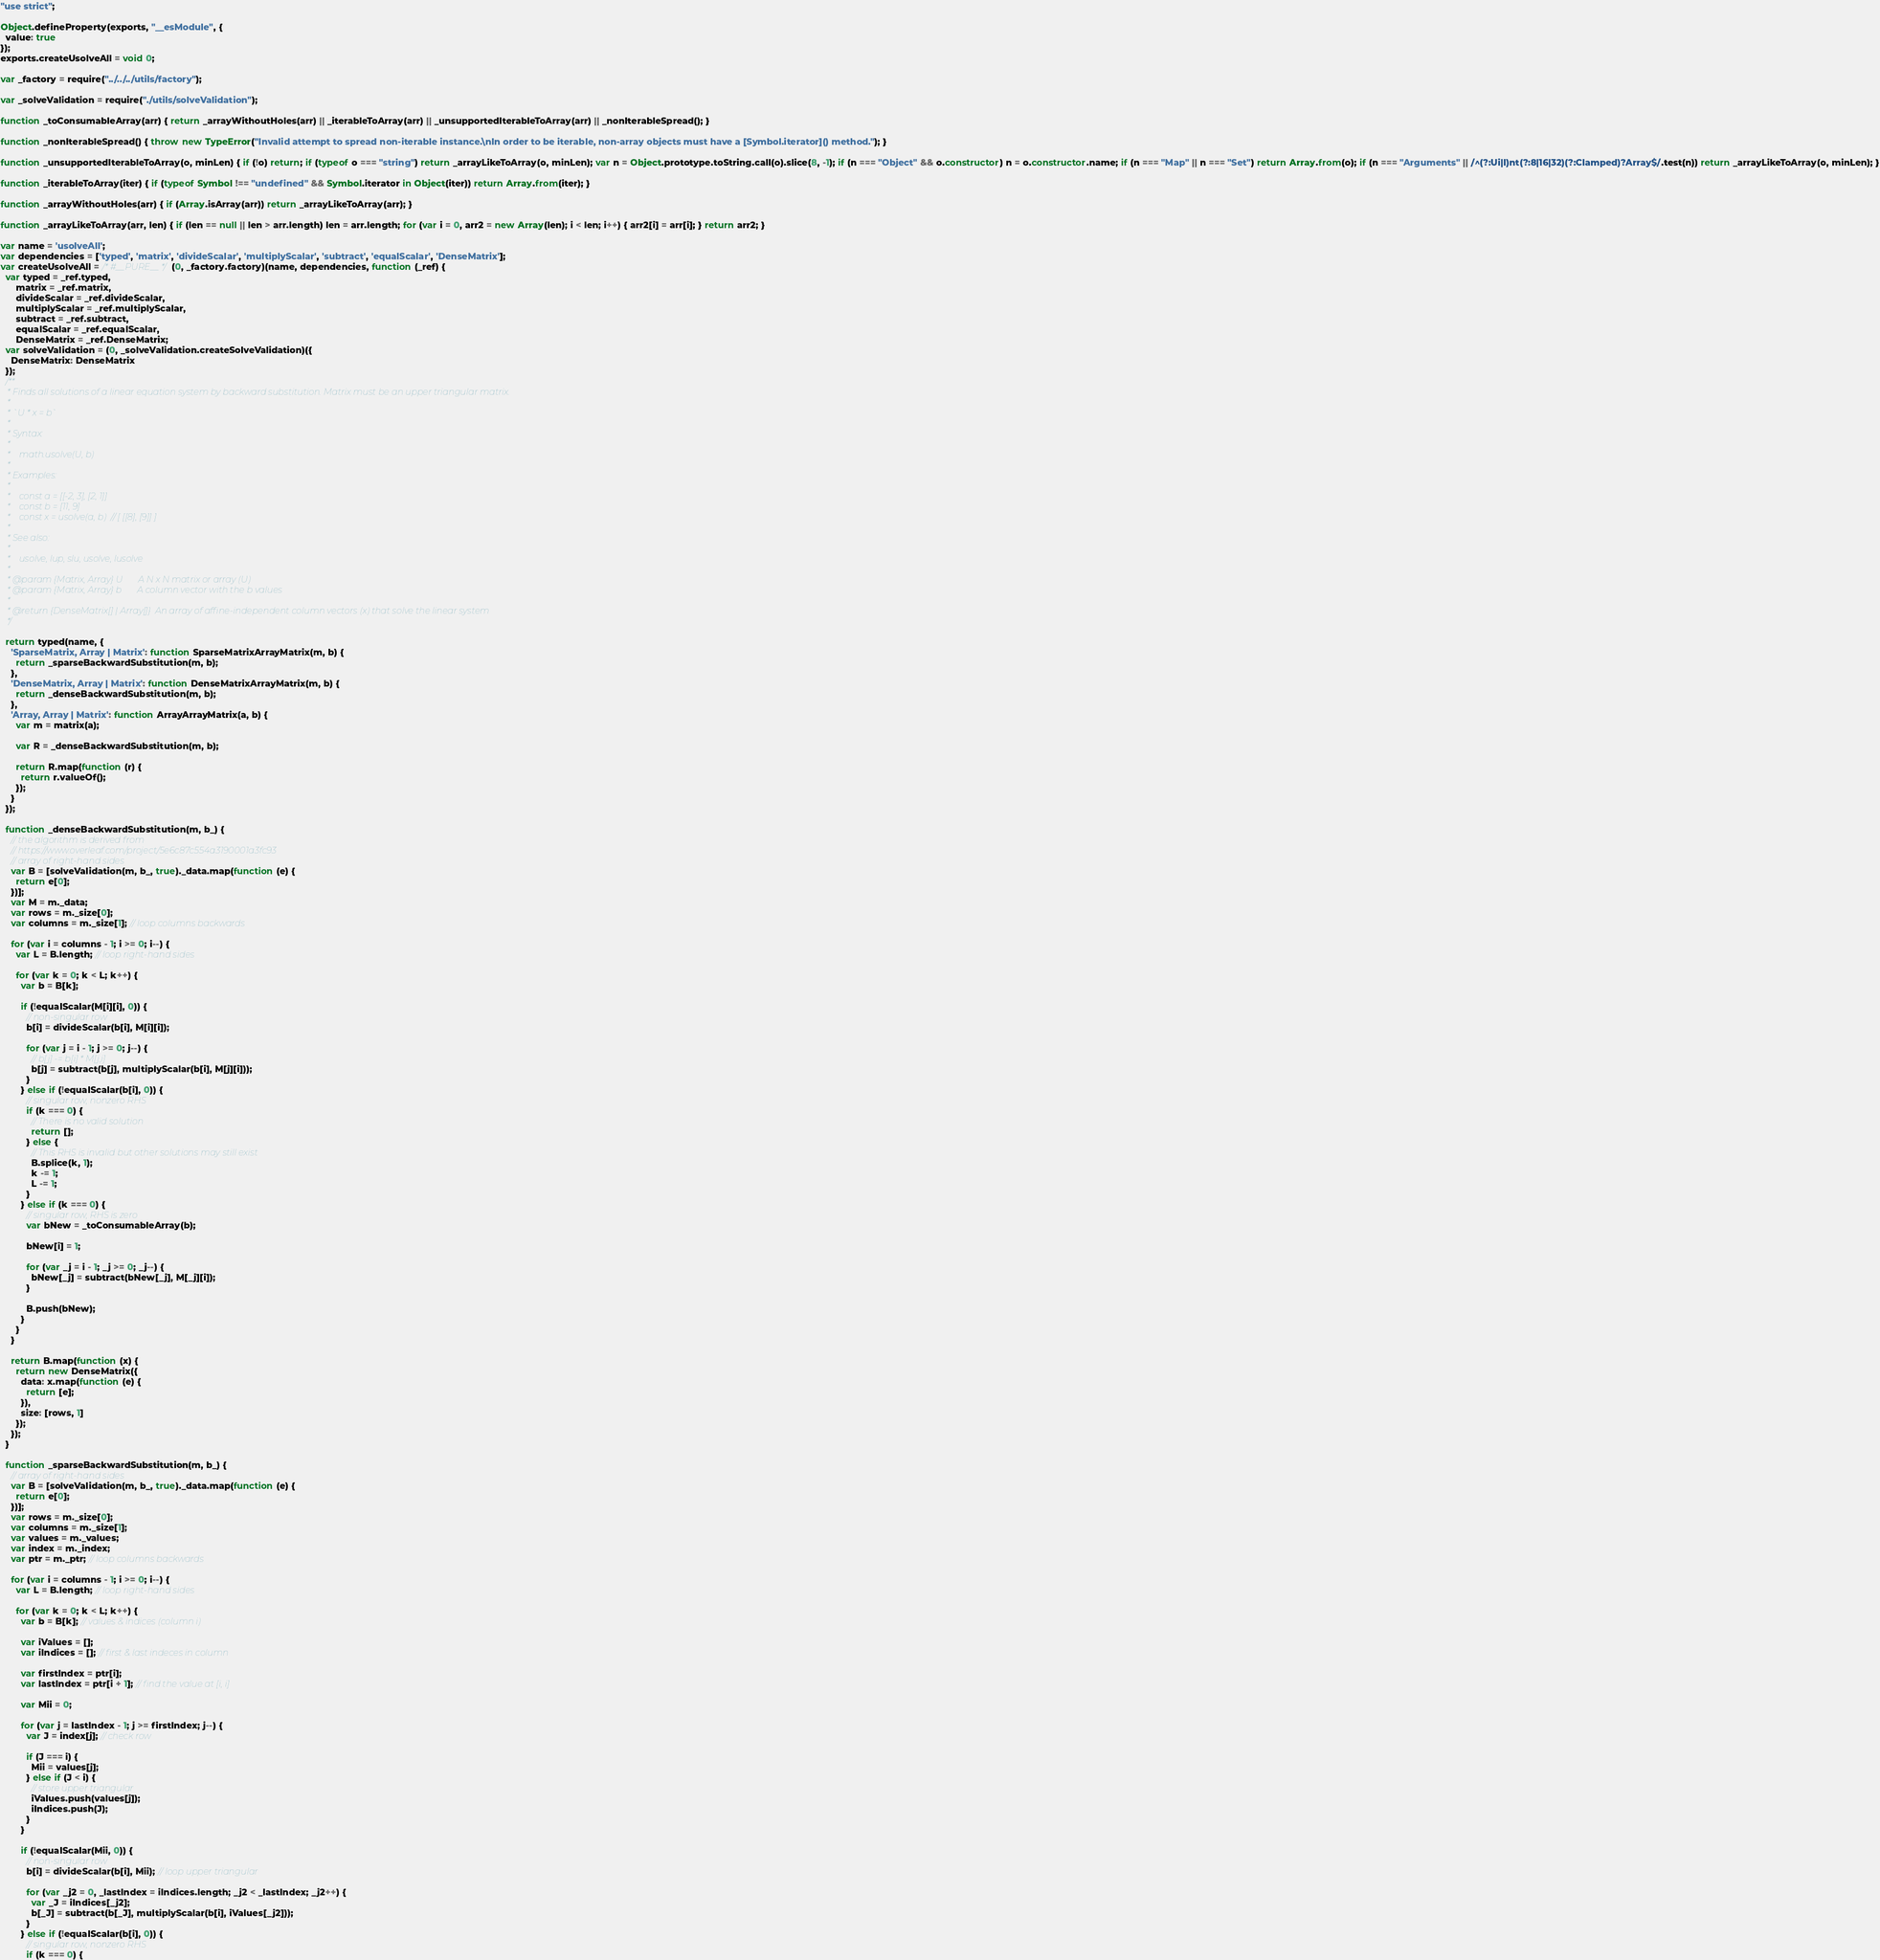<code> <loc_0><loc_0><loc_500><loc_500><_JavaScript_>"use strict";

Object.defineProperty(exports, "__esModule", {
  value: true
});
exports.createUsolveAll = void 0;

var _factory = require("../../../utils/factory");

var _solveValidation = require("./utils/solveValidation");

function _toConsumableArray(arr) { return _arrayWithoutHoles(arr) || _iterableToArray(arr) || _unsupportedIterableToArray(arr) || _nonIterableSpread(); }

function _nonIterableSpread() { throw new TypeError("Invalid attempt to spread non-iterable instance.\nIn order to be iterable, non-array objects must have a [Symbol.iterator]() method."); }

function _unsupportedIterableToArray(o, minLen) { if (!o) return; if (typeof o === "string") return _arrayLikeToArray(o, minLen); var n = Object.prototype.toString.call(o).slice(8, -1); if (n === "Object" && o.constructor) n = o.constructor.name; if (n === "Map" || n === "Set") return Array.from(o); if (n === "Arguments" || /^(?:Ui|I)nt(?:8|16|32)(?:Clamped)?Array$/.test(n)) return _arrayLikeToArray(o, minLen); }

function _iterableToArray(iter) { if (typeof Symbol !== "undefined" && Symbol.iterator in Object(iter)) return Array.from(iter); }

function _arrayWithoutHoles(arr) { if (Array.isArray(arr)) return _arrayLikeToArray(arr); }

function _arrayLikeToArray(arr, len) { if (len == null || len > arr.length) len = arr.length; for (var i = 0, arr2 = new Array(len); i < len; i++) { arr2[i] = arr[i]; } return arr2; }

var name = 'usolveAll';
var dependencies = ['typed', 'matrix', 'divideScalar', 'multiplyScalar', 'subtract', 'equalScalar', 'DenseMatrix'];
var createUsolveAll = /* #__PURE__ */(0, _factory.factory)(name, dependencies, function (_ref) {
  var typed = _ref.typed,
      matrix = _ref.matrix,
      divideScalar = _ref.divideScalar,
      multiplyScalar = _ref.multiplyScalar,
      subtract = _ref.subtract,
      equalScalar = _ref.equalScalar,
      DenseMatrix = _ref.DenseMatrix;
  var solveValidation = (0, _solveValidation.createSolveValidation)({
    DenseMatrix: DenseMatrix
  });
  /**
   * Finds all solutions of a linear equation system by backward substitution. Matrix must be an upper triangular matrix.
   *
   * `U * x = b`
   *
   * Syntax:
   *
   *    math.usolve(U, b)
   *
   * Examples:
   *
   *    const a = [[-2, 3], [2, 1]]
   *    const b = [11, 9]
   *    const x = usolve(a, b)  // [ [[8], [9]] ]
   *
   * See also:
   *
   *    usolve, lup, slu, usolve, lusolve
   *
   * @param {Matrix, Array} U       A N x N matrix or array (U)
   * @param {Matrix, Array} b       A column vector with the b values
   *
   * @return {DenseMatrix[] | Array[]}  An array of affine-independent column vectors (x) that solve the linear system
   */

  return typed(name, {
    'SparseMatrix, Array | Matrix': function SparseMatrixArrayMatrix(m, b) {
      return _sparseBackwardSubstitution(m, b);
    },
    'DenseMatrix, Array | Matrix': function DenseMatrixArrayMatrix(m, b) {
      return _denseBackwardSubstitution(m, b);
    },
    'Array, Array | Matrix': function ArrayArrayMatrix(a, b) {
      var m = matrix(a);

      var R = _denseBackwardSubstitution(m, b);

      return R.map(function (r) {
        return r.valueOf();
      });
    }
  });

  function _denseBackwardSubstitution(m, b_) {
    // the algorithm is derived from
    // https://www.overleaf.com/project/5e6c87c554a3190001a3fc93
    // array of right-hand sides
    var B = [solveValidation(m, b_, true)._data.map(function (e) {
      return e[0];
    })];
    var M = m._data;
    var rows = m._size[0];
    var columns = m._size[1]; // loop columns backwards

    for (var i = columns - 1; i >= 0; i--) {
      var L = B.length; // loop right-hand sides

      for (var k = 0; k < L; k++) {
        var b = B[k];

        if (!equalScalar(M[i][i], 0)) {
          // non-singular row
          b[i] = divideScalar(b[i], M[i][i]);

          for (var j = i - 1; j >= 0; j--) {
            // b[j] -= b[i] * M[j,i]
            b[j] = subtract(b[j], multiplyScalar(b[i], M[j][i]));
          }
        } else if (!equalScalar(b[i], 0)) {
          // singular row, nonzero RHS
          if (k === 0) {
            // There is no valid solution
            return [];
          } else {
            // This RHS is invalid but other solutions may still exist
            B.splice(k, 1);
            k -= 1;
            L -= 1;
          }
        } else if (k === 0) {
          // singular row, RHS is zero
          var bNew = _toConsumableArray(b);

          bNew[i] = 1;

          for (var _j = i - 1; _j >= 0; _j--) {
            bNew[_j] = subtract(bNew[_j], M[_j][i]);
          }

          B.push(bNew);
        }
      }
    }

    return B.map(function (x) {
      return new DenseMatrix({
        data: x.map(function (e) {
          return [e];
        }),
        size: [rows, 1]
      });
    });
  }

  function _sparseBackwardSubstitution(m, b_) {
    // array of right-hand sides
    var B = [solveValidation(m, b_, true)._data.map(function (e) {
      return e[0];
    })];
    var rows = m._size[0];
    var columns = m._size[1];
    var values = m._values;
    var index = m._index;
    var ptr = m._ptr; // loop columns backwards

    for (var i = columns - 1; i >= 0; i--) {
      var L = B.length; // loop right-hand sides

      for (var k = 0; k < L; k++) {
        var b = B[k]; // values & indices (column i)

        var iValues = [];
        var iIndices = []; // first & last indeces in column

        var firstIndex = ptr[i];
        var lastIndex = ptr[i + 1]; // find the value at [i, i]

        var Mii = 0;

        for (var j = lastIndex - 1; j >= firstIndex; j--) {
          var J = index[j]; // check row

          if (J === i) {
            Mii = values[j];
          } else if (J < i) {
            // store upper triangular
            iValues.push(values[j]);
            iIndices.push(J);
          }
        }

        if (!equalScalar(Mii, 0)) {
          // non-singular row
          b[i] = divideScalar(b[i], Mii); // loop upper triangular

          for (var _j2 = 0, _lastIndex = iIndices.length; _j2 < _lastIndex; _j2++) {
            var _J = iIndices[_j2];
            b[_J] = subtract(b[_J], multiplyScalar(b[i], iValues[_j2]));
          }
        } else if (!equalScalar(b[i], 0)) {
          // singular row, nonzero RHS
          if (k === 0) {</code> 